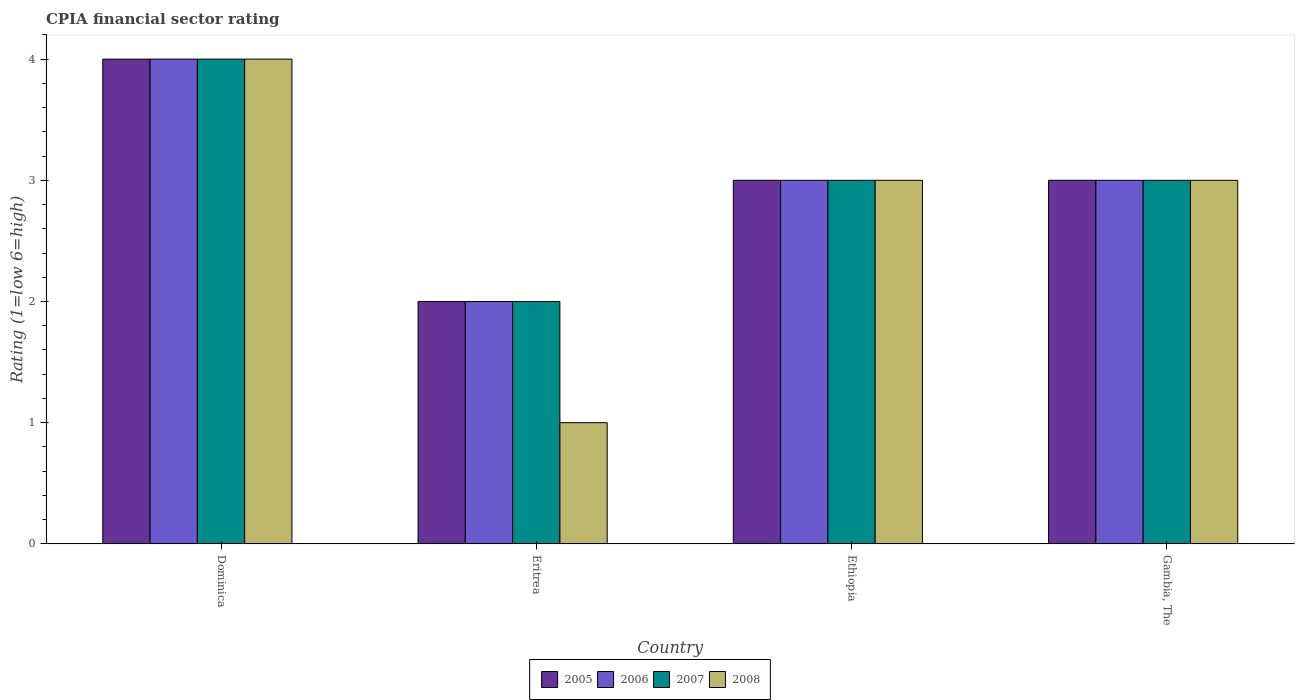How many groups of bars are there?
Your answer should be compact. 4. Are the number of bars on each tick of the X-axis equal?
Your answer should be very brief. Yes. What is the label of the 4th group of bars from the left?
Make the answer very short. Gambia, The. In how many cases, is the number of bars for a given country not equal to the number of legend labels?
Ensure brevity in your answer.  0. In which country was the CPIA rating in 2005 maximum?
Give a very brief answer. Dominica. In which country was the CPIA rating in 2005 minimum?
Offer a very short reply. Eritrea. What is the total CPIA rating in 2005 in the graph?
Give a very brief answer. 12. What is the difference between the CPIA rating in 2006 in Eritrea and that in Ethiopia?
Keep it short and to the point. -1. What is the difference between the CPIA rating in 2008 in Dominica and the CPIA rating in 2007 in Ethiopia?
Offer a terse response. 1. What is the difference between the CPIA rating of/in 2007 and CPIA rating of/in 2005 in Ethiopia?
Your answer should be compact. 0. In how many countries, is the CPIA rating in 2006 greater than 2.8?
Keep it short and to the point. 3. What is the ratio of the CPIA rating in 2007 in Dominica to that in Eritrea?
Make the answer very short. 2. Is the CPIA rating in 2007 in Dominica less than that in Ethiopia?
Provide a short and direct response. No. What is the difference between the highest and the lowest CPIA rating in 2007?
Make the answer very short. 2. In how many countries, is the CPIA rating in 2008 greater than the average CPIA rating in 2008 taken over all countries?
Your answer should be compact. 3. Is the sum of the CPIA rating in 2008 in Dominica and Gambia, The greater than the maximum CPIA rating in 2005 across all countries?
Your answer should be compact. Yes. Is it the case that in every country, the sum of the CPIA rating in 2006 and CPIA rating in 2007 is greater than the sum of CPIA rating in 2008 and CPIA rating in 2005?
Provide a succinct answer. No. What does the 2nd bar from the right in Eritrea represents?
Provide a succinct answer. 2007. Is it the case that in every country, the sum of the CPIA rating in 2006 and CPIA rating in 2007 is greater than the CPIA rating in 2008?
Ensure brevity in your answer.  Yes. How many bars are there?
Ensure brevity in your answer.  16. How many countries are there in the graph?
Keep it short and to the point. 4. What is the difference between two consecutive major ticks on the Y-axis?
Your answer should be very brief. 1. Does the graph contain any zero values?
Ensure brevity in your answer.  No. Where does the legend appear in the graph?
Keep it short and to the point. Bottom center. What is the title of the graph?
Keep it short and to the point. CPIA financial sector rating. Does "2013" appear as one of the legend labels in the graph?
Provide a short and direct response. No. What is the Rating (1=low 6=high) of 2007 in Dominica?
Provide a short and direct response. 4. What is the Rating (1=low 6=high) in 2007 in Eritrea?
Give a very brief answer. 2. What is the Rating (1=low 6=high) of 2007 in Ethiopia?
Keep it short and to the point. 3. What is the Rating (1=low 6=high) in 2005 in Gambia, The?
Make the answer very short. 3. What is the Rating (1=low 6=high) of 2007 in Gambia, The?
Your answer should be very brief. 3. Across all countries, what is the maximum Rating (1=low 6=high) of 2005?
Ensure brevity in your answer.  4. Across all countries, what is the maximum Rating (1=low 6=high) of 2007?
Your answer should be compact. 4. Across all countries, what is the maximum Rating (1=low 6=high) of 2008?
Give a very brief answer. 4. Across all countries, what is the minimum Rating (1=low 6=high) in 2005?
Provide a short and direct response. 2. Across all countries, what is the minimum Rating (1=low 6=high) of 2007?
Give a very brief answer. 2. What is the total Rating (1=low 6=high) of 2006 in the graph?
Provide a short and direct response. 12. What is the total Rating (1=low 6=high) of 2007 in the graph?
Make the answer very short. 12. What is the difference between the Rating (1=low 6=high) in 2007 in Dominica and that in Eritrea?
Provide a succinct answer. 2. What is the difference between the Rating (1=low 6=high) in 2008 in Dominica and that in Eritrea?
Keep it short and to the point. 3. What is the difference between the Rating (1=low 6=high) of 2005 in Dominica and that in Ethiopia?
Provide a short and direct response. 1. What is the difference between the Rating (1=low 6=high) in 2007 in Dominica and that in Ethiopia?
Your response must be concise. 1. What is the difference between the Rating (1=low 6=high) of 2005 in Dominica and that in Gambia, The?
Your answer should be very brief. 1. What is the difference between the Rating (1=low 6=high) in 2006 in Eritrea and that in Ethiopia?
Give a very brief answer. -1. What is the difference between the Rating (1=low 6=high) in 2008 in Eritrea and that in Ethiopia?
Provide a short and direct response. -2. What is the difference between the Rating (1=low 6=high) in 2006 in Eritrea and that in Gambia, The?
Your answer should be very brief. -1. What is the difference between the Rating (1=low 6=high) in 2007 in Eritrea and that in Gambia, The?
Your answer should be compact. -1. What is the difference between the Rating (1=low 6=high) in 2005 in Ethiopia and that in Gambia, The?
Ensure brevity in your answer.  0. What is the difference between the Rating (1=low 6=high) of 2007 in Ethiopia and that in Gambia, The?
Your answer should be compact. 0. What is the difference between the Rating (1=low 6=high) of 2008 in Ethiopia and that in Gambia, The?
Provide a short and direct response. 0. What is the difference between the Rating (1=low 6=high) of 2005 in Dominica and the Rating (1=low 6=high) of 2006 in Eritrea?
Your answer should be compact. 2. What is the difference between the Rating (1=low 6=high) of 2005 in Dominica and the Rating (1=low 6=high) of 2007 in Eritrea?
Your answer should be compact. 2. What is the difference between the Rating (1=low 6=high) in 2006 in Dominica and the Rating (1=low 6=high) in 2008 in Eritrea?
Keep it short and to the point. 3. What is the difference between the Rating (1=low 6=high) in 2007 in Dominica and the Rating (1=low 6=high) in 2008 in Eritrea?
Offer a terse response. 3. What is the difference between the Rating (1=low 6=high) of 2005 in Dominica and the Rating (1=low 6=high) of 2008 in Ethiopia?
Offer a very short reply. 1. What is the difference between the Rating (1=low 6=high) of 2006 in Dominica and the Rating (1=low 6=high) of 2008 in Ethiopia?
Make the answer very short. 1. What is the difference between the Rating (1=low 6=high) in 2007 in Dominica and the Rating (1=low 6=high) in 2008 in Ethiopia?
Your response must be concise. 1. What is the difference between the Rating (1=low 6=high) in 2005 in Dominica and the Rating (1=low 6=high) in 2006 in Gambia, The?
Ensure brevity in your answer.  1. What is the difference between the Rating (1=low 6=high) in 2006 in Dominica and the Rating (1=low 6=high) in 2007 in Gambia, The?
Offer a terse response. 1. What is the difference between the Rating (1=low 6=high) of 2006 in Dominica and the Rating (1=low 6=high) of 2008 in Gambia, The?
Your answer should be very brief. 1. What is the difference between the Rating (1=low 6=high) of 2007 in Dominica and the Rating (1=low 6=high) of 2008 in Gambia, The?
Provide a short and direct response. 1. What is the difference between the Rating (1=low 6=high) of 2005 in Eritrea and the Rating (1=low 6=high) of 2006 in Ethiopia?
Your response must be concise. -1. What is the difference between the Rating (1=low 6=high) in 2005 in Eritrea and the Rating (1=low 6=high) in 2007 in Ethiopia?
Make the answer very short. -1. What is the difference between the Rating (1=low 6=high) in 2007 in Eritrea and the Rating (1=low 6=high) in 2008 in Ethiopia?
Ensure brevity in your answer.  -1. What is the difference between the Rating (1=low 6=high) in 2005 in Eritrea and the Rating (1=low 6=high) in 2006 in Gambia, The?
Provide a succinct answer. -1. What is the difference between the Rating (1=low 6=high) of 2005 in Eritrea and the Rating (1=low 6=high) of 2007 in Gambia, The?
Your answer should be very brief. -1. What is the difference between the Rating (1=low 6=high) of 2006 in Eritrea and the Rating (1=low 6=high) of 2008 in Gambia, The?
Your answer should be very brief. -1. What is the difference between the Rating (1=low 6=high) of 2005 in Ethiopia and the Rating (1=low 6=high) of 2006 in Gambia, The?
Ensure brevity in your answer.  0. What is the difference between the Rating (1=low 6=high) of 2005 in Ethiopia and the Rating (1=low 6=high) of 2007 in Gambia, The?
Your answer should be very brief. 0. What is the difference between the Rating (1=low 6=high) in 2006 in Ethiopia and the Rating (1=low 6=high) in 2008 in Gambia, The?
Provide a succinct answer. 0. What is the difference between the Rating (1=low 6=high) of 2007 in Ethiopia and the Rating (1=low 6=high) of 2008 in Gambia, The?
Make the answer very short. 0. What is the average Rating (1=low 6=high) in 2007 per country?
Provide a short and direct response. 3. What is the average Rating (1=low 6=high) in 2008 per country?
Your answer should be compact. 2.75. What is the difference between the Rating (1=low 6=high) in 2006 and Rating (1=low 6=high) in 2007 in Dominica?
Your response must be concise. 0. What is the difference between the Rating (1=low 6=high) of 2006 and Rating (1=low 6=high) of 2008 in Dominica?
Your answer should be very brief. 0. What is the difference between the Rating (1=low 6=high) in 2007 and Rating (1=low 6=high) in 2008 in Dominica?
Make the answer very short. 0. What is the difference between the Rating (1=low 6=high) of 2005 and Rating (1=low 6=high) of 2008 in Eritrea?
Provide a short and direct response. 1. What is the difference between the Rating (1=low 6=high) of 2007 and Rating (1=low 6=high) of 2008 in Eritrea?
Provide a short and direct response. 1. What is the difference between the Rating (1=low 6=high) in 2005 and Rating (1=low 6=high) in 2008 in Ethiopia?
Offer a terse response. 0. What is the difference between the Rating (1=low 6=high) in 2005 and Rating (1=low 6=high) in 2007 in Gambia, The?
Ensure brevity in your answer.  0. What is the difference between the Rating (1=low 6=high) in 2005 and Rating (1=low 6=high) in 2008 in Gambia, The?
Provide a short and direct response. 0. What is the difference between the Rating (1=low 6=high) in 2006 and Rating (1=low 6=high) in 2007 in Gambia, The?
Keep it short and to the point. 0. What is the difference between the Rating (1=low 6=high) in 2006 and Rating (1=low 6=high) in 2008 in Gambia, The?
Your answer should be very brief. 0. What is the difference between the Rating (1=low 6=high) in 2007 and Rating (1=low 6=high) in 2008 in Gambia, The?
Ensure brevity in your answer.  0. What is the ratio of the Rating (1=low 6=high) of 2005 in Dominica to that in Eritrea?
Provide a short and direct response. 2. What is the ratio of the Rating (1=low 6=high) in 2006 in Dominica to that in Eritrea?
Your response must be concise. 2. What is the ratio of the Rating (1=low 6=high) in 2007 in Dominica to that in Eritrea?
Provide a succinct answer. 2. What is the ratio of the Rating (1=low 6=high) of 2008 in Dominica to that in Eritrea?
Keep it short and to the point. 4. What is the ratio of the Rating (1=low 6=high) in 2008 in Dominica to that in Gambia, The?
Provide a short and direct response. 1.33. What is the ratio of the Rating (1=low 6=high) in 2006 in Eritrea to that in Ethiopia?
Ensure brevity in your answer.  0.67. What is the ratio of the Rating (1=low 6=high) of 2006 in Eritrea to that in Gambia, The?
Provide a short and direct response. 0.67. What is the ratio of the Rating (1=low 6=high) in 2007 in Eritrea to that in Gambia, The?
Provide a short and direct response. 0.67. What is the ratio of the Rating (1=low 6=high) in 2008 in Eritrea to that in Gambia, The?
Provide a short and direct response. 0.33. What is the ratio of the Rating (1=low 6=high) of 2005 in Ethiopia to that in Gambia, The?
Keep it short and to the point. 1. What is the ratio of the Rating (1=low 6=high) in 2007 in Ethiopia to that in Gambia, The?
Ensure brevity in your answer.  1. What is the ratio of the Rating (1=low 6=high) of 2008 in Ethiopia to that in Gambia, The?
Provide a succinct answer. 1. What is the difference between the highest and the second highest Rating (1=low 6=high) in 2007?
Provide a succinct answer. 1. What is the difference between the highest and the second highest Rating (1=low 6=high) in 2008?
Ensure brevity in your answer.  1. What is the difference between the highest and the lowest Rating (1=low 6=high) in 2005?
Ensure brevity in your answer.  2. What is the difference between the highest and the lowest Rating (1=low 6=high) of 2007?
Offer a terse response. 2. 